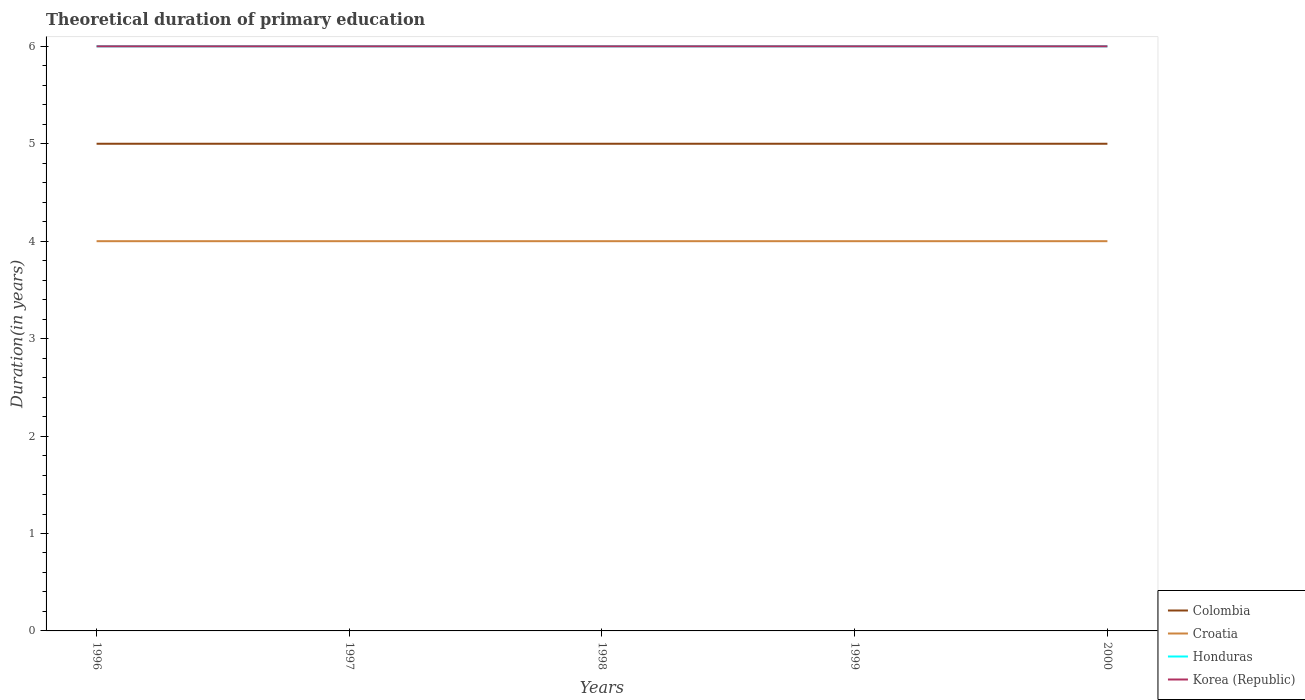How many different coloured lines are there?
Make the answer very short. 4. Across all years, what is the maximum total theoretical duration of primary education in Korea (Republic)?
Offer a very short reply. 6. In which year was the total theoretical duration of primary education in Croatia maximum?
Your answer should be compact. 1996. What is the difference between the highest and the second highest total theoretical duration of primary education in Croatia?
Make the answer very short. 0. What is the difference between the highest and the lowest total theoretical duration of primary education in Honduras?
Your answer should be compact. 0. Is the total theoretical duration of primary education in Croatia strictly greater than the total theoretical duration of primary education in Colombia over the years?
Give a very brief answer. Yes. How many lines are there?
Your answer should be very brief. 4. How many years are there in the graph?
Offer a very short reply. 5. What is the difference between two consecutive major ticks on the Y-axis?
Keep it short and to the point. 1. Are the values on the major ticks of Y-axis written in scientific E-notation?
Keep it short and to the point. No. Where does the legend appear in the graph?
Offer a very short reply. Bottom right. How are the legend labels stacked?
Your response must be concise. Vertical. What is the title of the graph?
Your answer should be compact. Theoretical duration of primary education. Does "Upper middle income" appear as one of the legend labels in the graph?
Offer a terse response. No. What is the label or title of the X-axis?
Your answer should be compact. Years. What is the label or title of the Y-axis?
Your answer should be compact. Duration(in years). What is the Duration(in years) in Croatia in 1996?
Provide a succinct answer. 4. What is the Duration(in years) of Honduras in 1996?
Provide a short and direct response. 6. What is the Duration(in years) of Korea (Republic) in 1996?
Ensure brevity in your answer.  6. What is the Duration(in years) of Colombia in 1998?
Make the answer very short. 5. What is the Duration(in years) of Honduras in 1998?
Make the answer very short. 6. What is the Duration(in years) of Colombia in 1999?
Give a very brief answer. 5. What is the Duration(in years) of Honduras in 1999?
Offer a terse response. 6. What is the Duration(in years) in Korea (Republic) in 1999?
Make the answer very short. 6. What is the Duration(in years) of Colombia in 2000?
Your answer should be compact. 5. What is the Duration(in years) of Croatia in 2000?
Offer a terse response. 4. What is the Duration(in years) of Korea (Republic) in 2000?
Offer a very short reply. 6. Across all years, what is the maximum Duration(in years) of Colombia?
Provide a succinct answer. 5. Across all years, what is the maximum Duration(in years) in Croatia?
Offer a very short reply. 4. Across all years, what is the maximum Duration(in years) in Honduras?
Provide a short and direct response. 6. Across all years, what is the minimum Duration(in years) of Honduras?
Your answer should be compact. 6. Across all years, what is the minimum Duration(in years) in Korea (Republic)?
Provide a succinct answer. 6. What is the total Duration(in years) in Colombia in the graph?
Your answer should be very brief. 25. What is the total Duration(in years) of Honduras in the graph?
Keep it short and to the point. 30. What is the total Duration(in years) of Korea (Republic) in the graph?
Your answer should be very brief. 30. What is the difference between the Duration(in years) in Colombia in 1996 and that in 1997?
Your response must be concise. 0. What is the difference between the Duration(in years) in Croatia in 1996 and that in 1997?
Your answer should be compact. 0. What is the difference between the Duration(in years) in Honduras in 1996 and that in 1997?
Offer a very short reply. 0. What is the difference between the Duration(in years) in Korea (Republic) in 1996 and that in 1997?
Offer a very short reply. 0. What is the difference between the Duration(in years) in Colombia in 1996 and that in 1998?
Make the answer very short. 0. What is the difference between the Duration(in years) of Croatia in 1996 and that in 1998?
Ensure brevity in your answer.  0. What is the difference between the Duration(in years) in Korea (Republic) in 1996 and that in 1998?
Offer a very short reply. 0. What is the difference between the Duration(in years) in Colombia in 1996 and that in 1999?
Offer a very short reply. 0. What is the difference between the Duration(in years) of Croatia in 1996 and that in 1999?
Ensure brevity in your answer.  0. What is the difference between the Duration(in years) of Korea (Republic) in 1996 and that in 2000?
Provide a short and direct response. 0. What is the difference between the Duration(in years) of Colombia in 1997 and that in 1998?
Your response must be concise. 0. What is the difference between the Duration(in years) of Croatia in 1997 and that in 1998?
Your answer should be compact. 0. What is the difference between the Duration(in years) of Korea (Republic) in 1997 and that in 1998?
Your answer should be very brief. 0. What is the difference between the Duration(in years) of Korea (Republic) in 1997 and that in 1999?
Ensure brevity in your answer.  0. What is the difference between the Duration(in years) of Colombia in 1997 and that in 2000?
Your answer should be very brief. 0. What is the difference between the Duration(in years) in Croatia in 1997 and that in 2000?
Keep it short and to the point. 0. What is the difference between the Duration(in years) in Colombia in 1998 and that in 1999?
Give a very brief answer. 0. What is the difference between the Duration(in years) in Korea (Republic) in 1998 and that in 1999?
Your answer should be compact. 0. What is the difference between the Duration(in years) in Colombia in 1998 and that in 2000?
Your response must be concise. 0. What is the difference between the Duration(in years) of Croatia in 1998 and that in 2000?
Your answer should be very brief. 0. What is the difference between the Duration(in years) in Korea (Republic) in 1998 and that in 2000?
Provide a short and direct response. 0. What is the difference between the Duration(in years) of Colombia in 1999 and that in 2000?
Ensure brevity in your answer.  0. What is the difference between the Duration(in years) in Korea (Republic) in 1999 and that in 2000?
Offer a terse response. 0. What is the difference between the Duration(in years) in Colombia in 1996 and the Duration(in years) in Korea (Republic) in 1997?
Provide a succinct answer. -1. What is the difference between the Duration(in years) of Croatia in 1996 and the Duration(in years) of Honduras in 1997?
Provide a short and direct response. -2. What is the difference between the Duration(in years) of Honduras in 1996 and the Duration(in years) of Korea (Republic) in 1997?
Ensure brevity in your answer.  0. What is the difference between the Duration(in years) in Colombia in 1996 and the Duration(in years) in Croatia in 1998?
Provide a short and direct response. 1. What is the difference between the Duration(in years) in Croatia in 1996 and the Duration(in years) in Korea (Republic) in 1998?
Give a very brief answer. -2. What is the difference between the Duration(in years) of Honduras in 1996 and the Duration(in years) of Korea (Republic) in 1998?
Offer a very short reply. 0. What is the difference between the Duration(in years) of Colombia in 1996 and the Duration(in years) of Croatia in 1999?
Your answer should be very brief. 1. What is the difference between the Duration(in years) of Colombia in 1996 and the Duration(in years) of Honduras in 1999?
Provide a short and direct response. -1. What is the difference between the Duration(in years) of Colombia in 1996 and the Duration(in years) of Honduras in 2000?
Your answer should be very brief. -1. What is the difference between the Duration(in years) of Colombia in 1996 and the Duration(in years) of Korea (Republic) in 2000?
Your answer should be very brief. -1. What is the difference between the Duration(in years) of Croatia in 1996 and the Duration(in years) of Honduras in 2000?
Offer a very short reply. -2. What is the difference between the Duration(in years) in Croatia in 1996 and the Duration(in years) in Korea (Republic) in 2000?
Make the answer very short. -2. What is the difference between the Duration(in years) in Colombia in 1997 and the Duration(in years) in Korea (Republic) in 1998?
Your answer should be compact. -1. What is the difference between the Duration(in years) in Croatia in 1997 and the Duration(in years) in Honduras in 1998?
Make the answer very short. -2. What is the difference between the Duration(in years) in Honduras in 1997 and the Duration(in years) in Korea (Republic) in 1998?
Keep it short and to the point. 0. What is the difference between the Duration(in years) of Colombia in 1997 and the Duration(in years) of Croatia in 1999?
Provide a short and direct response. 1. What is the difference between the Duration(in years) in Croatia in 1997 and the Duration(in years) in Korea (Republic) in 1999?
Your answer should be very brief. -2. What is the difference between the Duration(in years) in Colombia in 1997 and the Duration(in years) in Croatia in 2000?
Ensure brevity in your answer.  1. What is the difference between the Duration(in years) of Colombia in 1997 and the Duration(in years) of Honduras in 2000?
Give a very brief answer. -1. What is the difference between the Duration(in years) of Croatia in 1997 and the Duration(in years) of Honduras in 2000?
Offer a very short reply. -2. What is the difference between the Duration(in years) of Honduras in 1997 and the Duration(in years) of Korea (Republic) in 2000?
Offer a very short reply. 0. What is the difference between the Duration(in years) of Colombia in 1998 and the Duration(in years) of Croatia in 1999?
Offer a terse response. 1. What is the difference between the Duration(in years) of Croatia in 1998 and the Duration(in years) of Honduras in 1999?
Keep it short and to the point. -2. What is the difference between the Duration(in years) of Croatia in 1998 and the Duration(in years) of Korea (Republic) in 1999?
Keep it short and to the point. -2. What is the difference between the Duration(in years) of Honduras in 1998 and the Duration(in years) of Korea (Republic) in 1999?
Offer a very short reply. 0. What is the difference between the Duration(in years) in Colombia in 1998 and the Duration(in years) in Croatia in 2000?
Offer a very short reply. 1. What is the difference between the Duration(in years) of Colombia in 1998 and the Duration(in years) of Korea (Republic) in 2000?
Keep it short and to the point. -1. What is the difference between the Duration(in years) in Croatia in 1998 and the Duration(in years) in Korea (Republic) in 2000?
Keep it short and to the point. -2. What is the difference between the Duration(in years) in Colombia in 1999 and the Duration(in years) in Croatia in 2000?
Offer a terse response. 1. What is the difference between the Duration(in years) of Colombia in 1999 and the Duration(in years) of Honduras in 2000?
Your answer should be compact. -1. What is the difference between the Duration(in years) of Honduras in 1999 and the Duration(in years) of Korea (Republic) in 2000?
Offer a terse response. 0. What is the average Duration(in years) of Colombia per year?
Your answer should be compact. 5. In the year 1996, what is the difference between the Duration(in years) of Colombia and Duration(in years) of Croatia?
Your answer should be very brief. 1. In the year 1996, what is the difference between the Duration(in years) of Colombia and Duration(in years) of Korea (Republic)?
Keep it short and to the point. -1. In the year 1996, what is the difference between the Duration(in years) in Croatia and Duration(in years) in Honduras?
Give a very brief answer. -2. In the year 1997, what is the difference between the Duration(in years) of Colombia and Duration(in years) of Croatia?
Your answer should be compact. 1. In the year 1997, what is the difference between the Duration(in years) in Colombia and Duration(in years) in Korea (Republic)?
Keep it short and to the point. -1. In the year 1997, what is the difference between the Duration(in years) of Croatia and Duration(in years) of Honduras?
Your response must be concise. -2. In the year 1998, what is the difference between the Duration(in years) of Colombia and Duration(in years) of Korea (Republic)?
Ensure brevity in your answer.  -1. In the year 1999, what is the difference between the Duration(in years) in Colombia and Duration(in years) in Croatia?
Keep it short and to the point. 1. In the year 1999, what is the difference between the Duration(in years) of Colombia and Duration(in years) of Honduras?
Offer a very short reply. -1. In the year 1999, what is the difference between the Duration(in years) of Colombia and Duration(in years) of Korea (Republic)?
Your response must be concise. -1. In the year 1999, what is the difference between the Duration(in years) in Croatia and Duration(in years) in Honduras?
Provide a short and direct response. -2. In the year 1999, what is the difference between the Duration(in years) of Croatia and Duration(in years) of Korea (Republic)?
Keep it short and to the point. -2. In the year 2000, what is the difference between the Duration(in years) in Colombia and Duration(in years) in Croatia?
Make the answer very short. 1. In the year 2000, what is the difference between the Duration(in years) in Croatia and Duration(in years) in Honduras?
Offer a very short reply. -2. In the year 2000, what is the difference between the Duration(in years) in Honduras and Duration(in years) in Korea (Republic)?
Give a very brief answer. 0. What is the ratio of the Duration(in years) of Honduras in 1996 to that in 1997?
Provide a succinct answer. 1. What is the ratio of the Duration(in years) of Korea (Republic) in 1996 to that in 1997?
Provide a succinct answer. 1. What is the ratio of the Duration(in years) in Honduras in 1996 to that in 1998?
Give a very brief answer. 1. What is the ratio of the Duration(in years) of Croatia in 1996 to that in 1999?
Give a very brief answer. 1. What is the ratio of the Duration(in years) in Honduras in 1996 to that in 1999?
Give a very brief answer. 1. What is the ratio of the Duration(in years) in Croatia in 1996 to that in 2000?
Provide a short and direct response. 1. What is the ratio of the Duration(in years) of Honduras in 1996 to that in 2000?
Ensure brevity in your answer.  1. What is the ratio of the Duration(in years) in Korea (Republic) in 1996 to that in 2000?
Provide a succinct answer. 1. What is the ratio of the Duration(in years) in Colombia in 1997 to that in 1998?
Give a very brief answer. 1. What is the ratio of the Duration(in years) in Honduras in 1997 to that in 1998?
Ensure brevity in your answer.  1. What is the ratio of the Duration(in years) of Korea (Republic) in 1997 to that in 1998?
Your response must be concise. 1. What is the ratio of the Duration(in years) of Croatia in 1997 to that in 1999?
Make the answer very short. 1. What is the ratio of the Duration(in years) of Honduras in 1997 to that in 1999?
Make the answer very short. 1. What is the ratio of the Duration(in years) of Korea (Republic) in 1997 to that in 1999?
Your answer should be compact. 1. What is the ratio of the Duration(in years) in Colombia in 1997 to that in 2000?
Make the answer very short. 1. What is the ratio of the Duration(in years) in Croatia in 1997 to that in 2000?
Offer a terse response. 1. What is the ratio of the Duration(in years) in Korea (Republic) in 1997 to that in 2000?
Keep it short and to the point. 1. What is the ratio of the Duration(in years) in Honduras in 1998 to that in 1999?
Provide a succinct answer. 1. What is the ratio of the Duration(in years) in Colombia in 1998 to that in 2000?
Provide a short and direct response. 1. What is the ratio of the Duration(in years) of Colombia in 1999 to that in 2000?
Make the answer very short. 1. What is the ratio of the Duration(in years) of Korea (Republic) in 1999 to that in 2000?
Provide a succinct answer. 1. What is the difference between the highest and the second highest Duration(in years) in Colombia?
Provide a short and direct response. 0. What is the difference between the highest and the second highest Duration(in years) of Croatia?
Give a very brief answer. 0. What is the difference between the highest and the second highest Duration(in years) of Honduras?
Your answer should be compact. 0. What is the difference between the highest and the second highest Duration(in years) of Korea (Republic)?
Give a very brief answer. 0. What is the difference between the highest and the lowest Duration(in years) of Colombia?
Your answer should be compact. 0. What is the difference between the highest and the lowest Duration(in years) of Honduras?
Provide a short and direct response. 0. What is the difference between the highest and the lowest Duration(in years) of Korea (Republic)?
Your answer should be very brief. 0. 